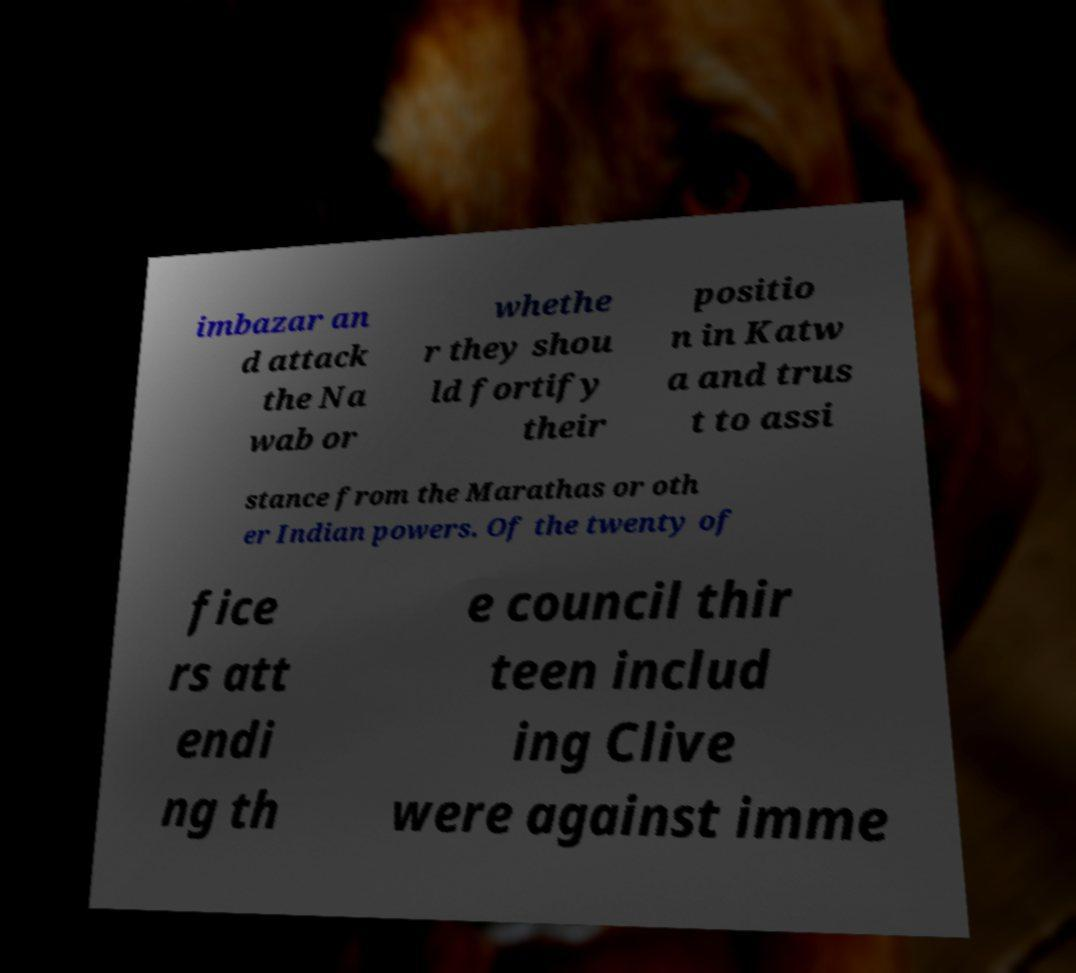Can you accurately transcribe the text from the provided image for me? imbazar an d attack the Na wab or whethe r they shou ld fortify their positio n in Katw a and trus t to assi stance from the Marathas or oth er Indian powers. Of the twenty of fice rs att endi ng th e council thir teen includ ing Clive were against imme 